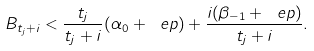<formula> <loc_0><loc_0><loc_500><loc_500>B _ { t _ { j } + i } < \frac { t _ { j } } { t _ { j } + i } ( \alpha _ { 0 } + \ e p ) + \frac { i ( \beta _ { - 1 } + \ e p ) } { t _ { j } + i } .</formula> 